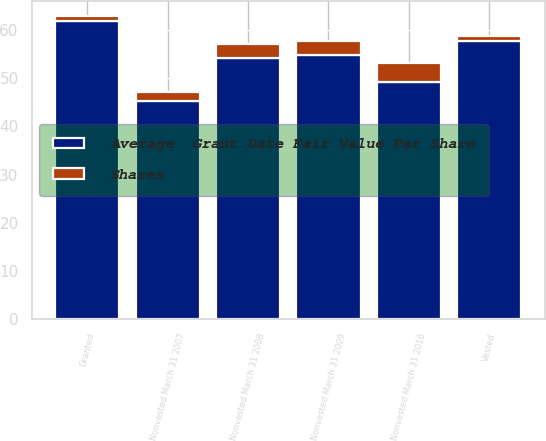Convert chart. <chart><loc_0><loc_0><loc_500><loc_500><stacked_bar_chart><ecel><fcel>Nonvested March 31 2007<fcel>Granted<fcel>Nonvested March 31 2008<fcel>Vested<fcel>Nonvested March 31 2009<fcel>Nonvested March 31 2010<nl><fcel>Shares<fcel>2<fcel>1<fcel>3<fcel>1<fcel>3<fcel>4<nl><fcel>Average  Grant Date Fair Value Per Share<fcel>45.18<fcel>61.92<fcel>54.13<fcel>57.61<fcel>54.7<fcel>49.21<nl></chart> 